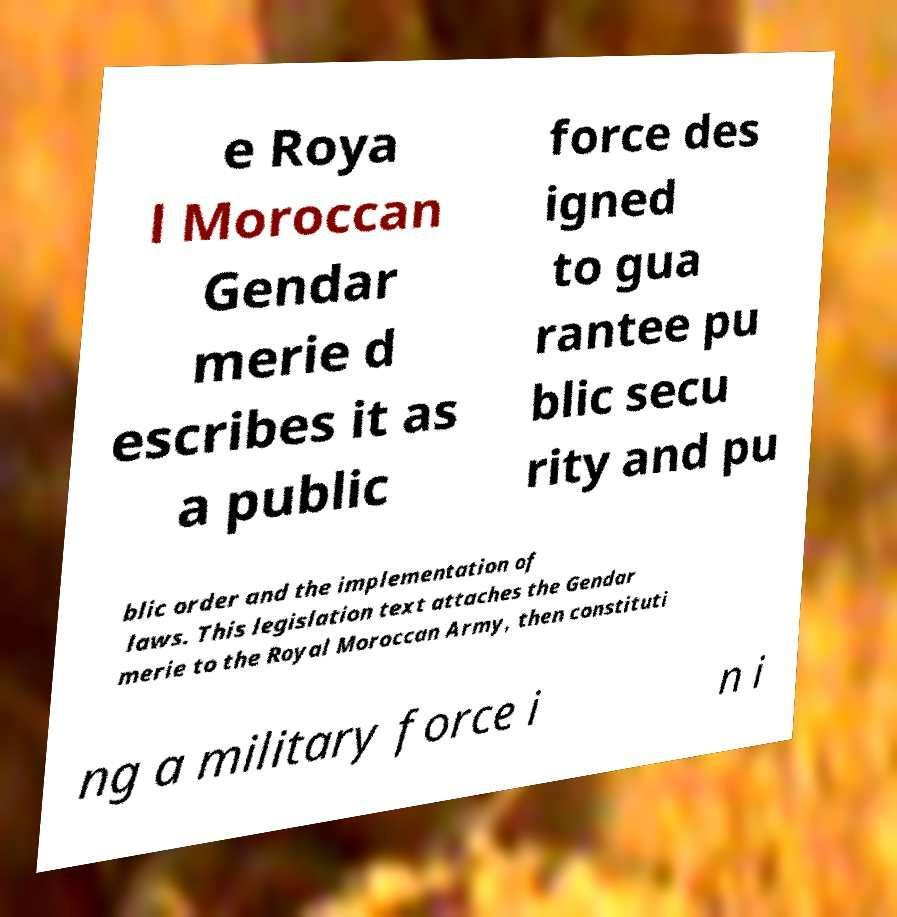Can you accurately transcribe the text from the provided image for me? e Roya l Moroccan Gendar merie d escribes it as a public force des igned to gua rantee pu blic secu rity and pu blic order and the implementation of laws. This legislation text attaches the Gendar merie to the Royal Moroccan Army, then constituti ng a military force i n i 